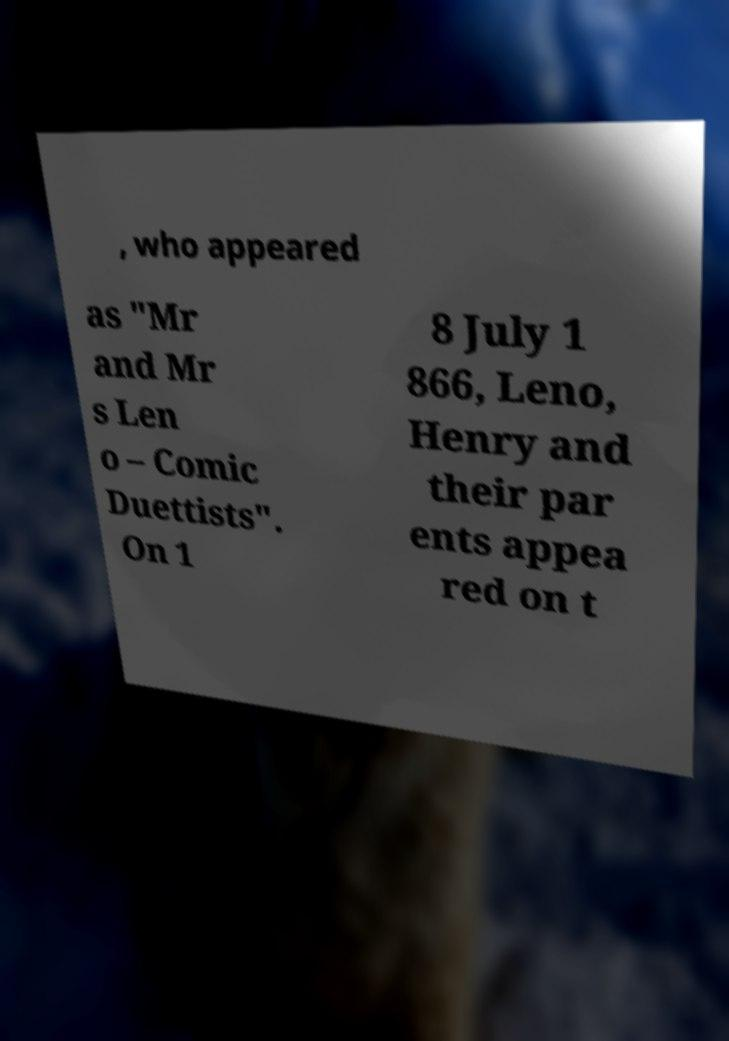Please identify and transcribe the text found in this image. , who appeared as "Mr and Mr s Len o – Comic Duettists". On 1 8 July 1 866, Leno, Henry and their par ents appea red on t 